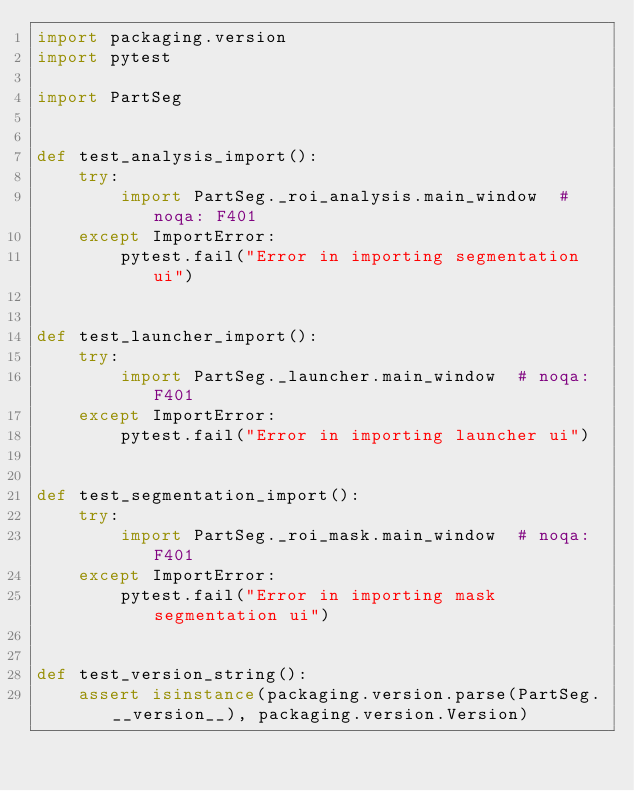<code> <loc_0><loc_0><loc_500><loc_500><_Python_>import packaging.version
import pytest

import PartSeg


def test_analysis_import():
    try:
        import PartSeg._roi_analysis.main_window  # noqa: F401
    except ImportError:
        pytest.fail("Error in importing segmentation ui")


def test_launcher_import():
    try:
        import PartSeg._launcher.main_window  # noqa: F401
    except ImportError:
        pytest.fail("Error in importing launcher ui")


def test_segmentation_import():
    try:
        import PartSeg._roi_mask.main_window  # noqa: F401
    except ImportError:
        pytest.fail("Error in importing mask segmentation ui")


def test_version_string():
    assert isinstance(packaging.version.parse(PartSeg.__version__), packaging.version.Version)
</code> 